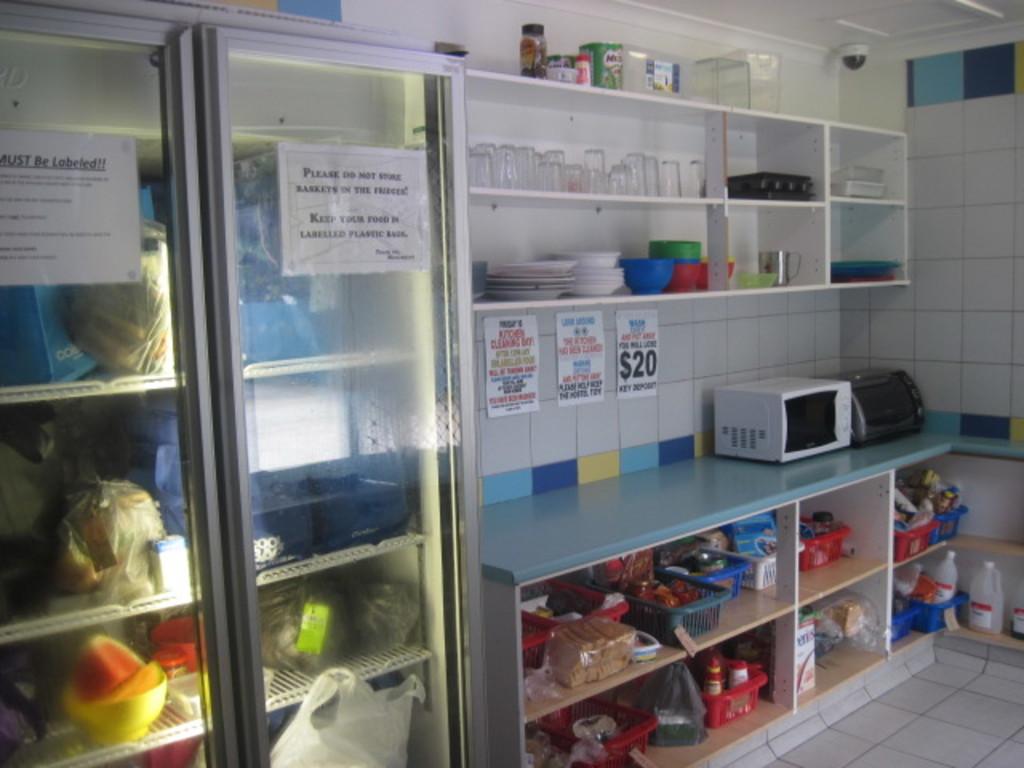How much is the cost on the paper by the microwave?
Your response must be concise. $20. 